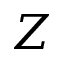<formula> <loc_0><loc_0><loc_500><loc_500>Z</formula> 